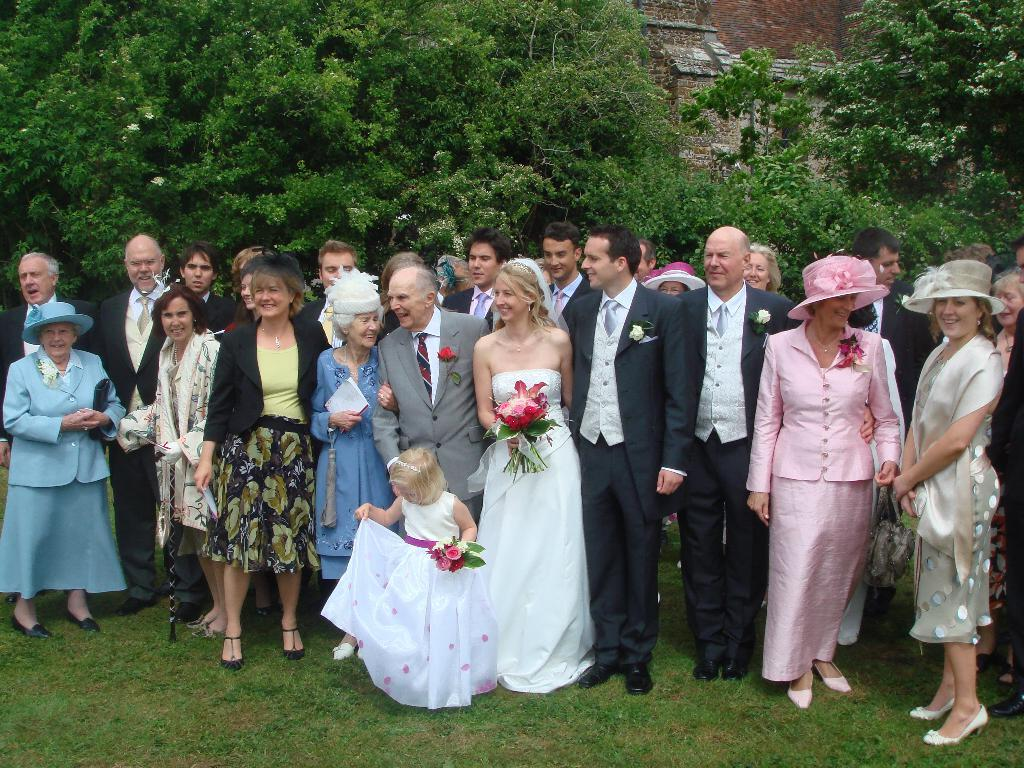What is located in the foreground of the picture? There is a group of people in the foreground of the picture. What type of vegetation is present in the foreground of the picture? Grass is present in the foreground of the picture. What can be seen in the background of the picture? There are trees and a building in the background of the picture. What type of salt is being used by the servant in the image? There is no servant or salt present in the image. What type of apparel are the people wearing in the image? The provided facts do not mention the apparel of the people in the image. 